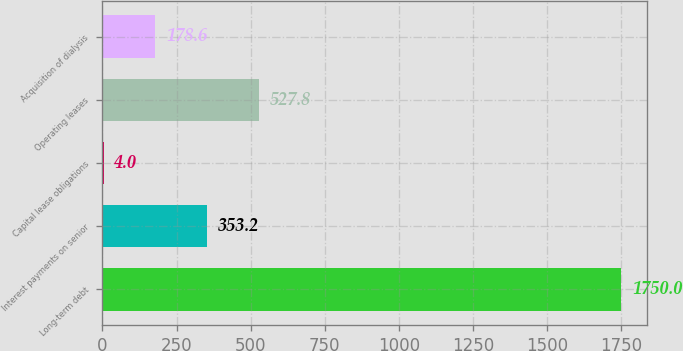Convert chart to OTSL. <chart><loc_0><loc_0><loc_500><loc_500><bar_chart><fcel>Long-term debt<fcel>Interest payments on senior<fcel>Capital lease obligations<fcel>Operating leases<fcel>Acquisition of dialysis<nl><fcel>1750<fcel>353.2<fcel>4<fcel>527.8<fcel>178.6<nl></chart> 